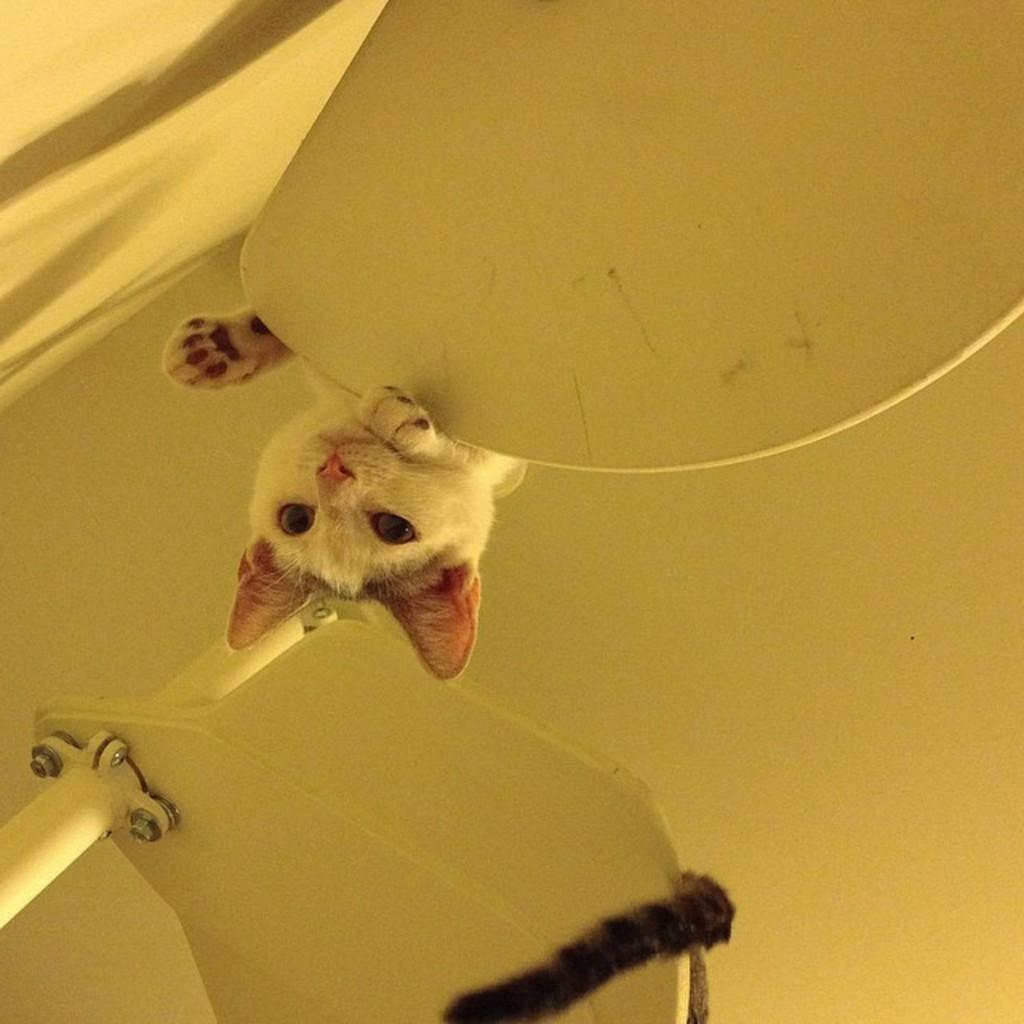Describe this image in one or two sentences. In the center of the picture we can see cat, a cat's tail, iron frame and some objects. In the background we can see a white object might be ceiling. On the left it might be wall. 